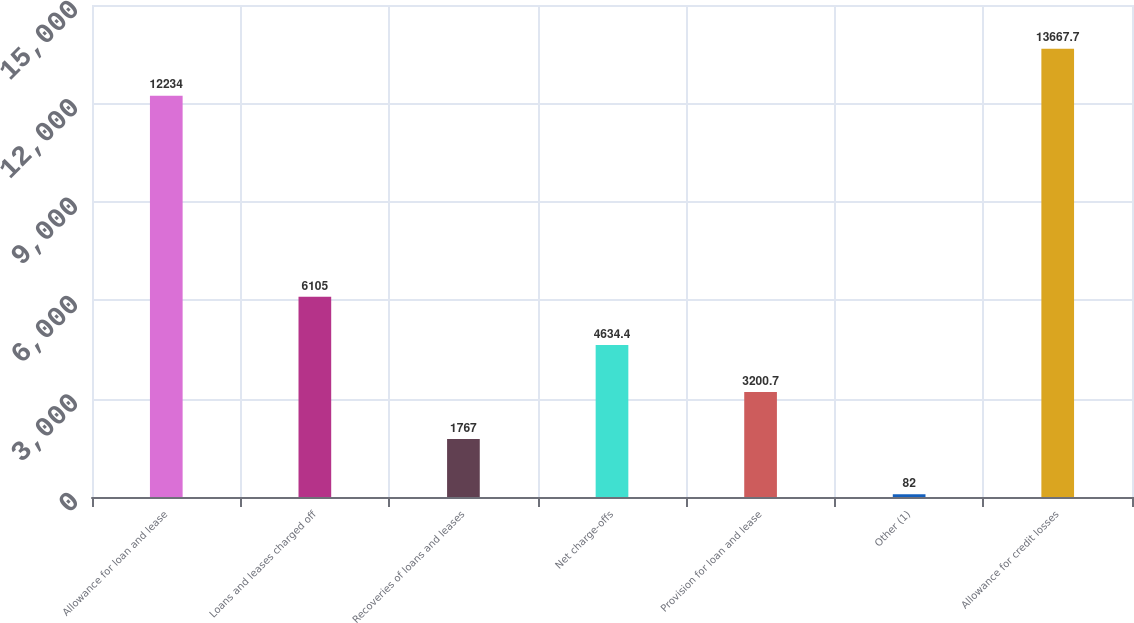Convert chart. <chart><loc_0><loc_0><loc_500><loc_500><bar_chart><fcel>Allowance for loan and lease<fcel>Loans and leases charged off<fcel>Recoveries of loans and leases<fcel>Net charge-offs<fcel>Provision for loan and lease<fcel>Other (1)<fcel>Allowance for credit losses<nl><fcel>12234<fcel>6105<fcel>1767<fcel>4634.4<fcel>3200.7<fcel>82<fcel>13667.7<nl></chart> 